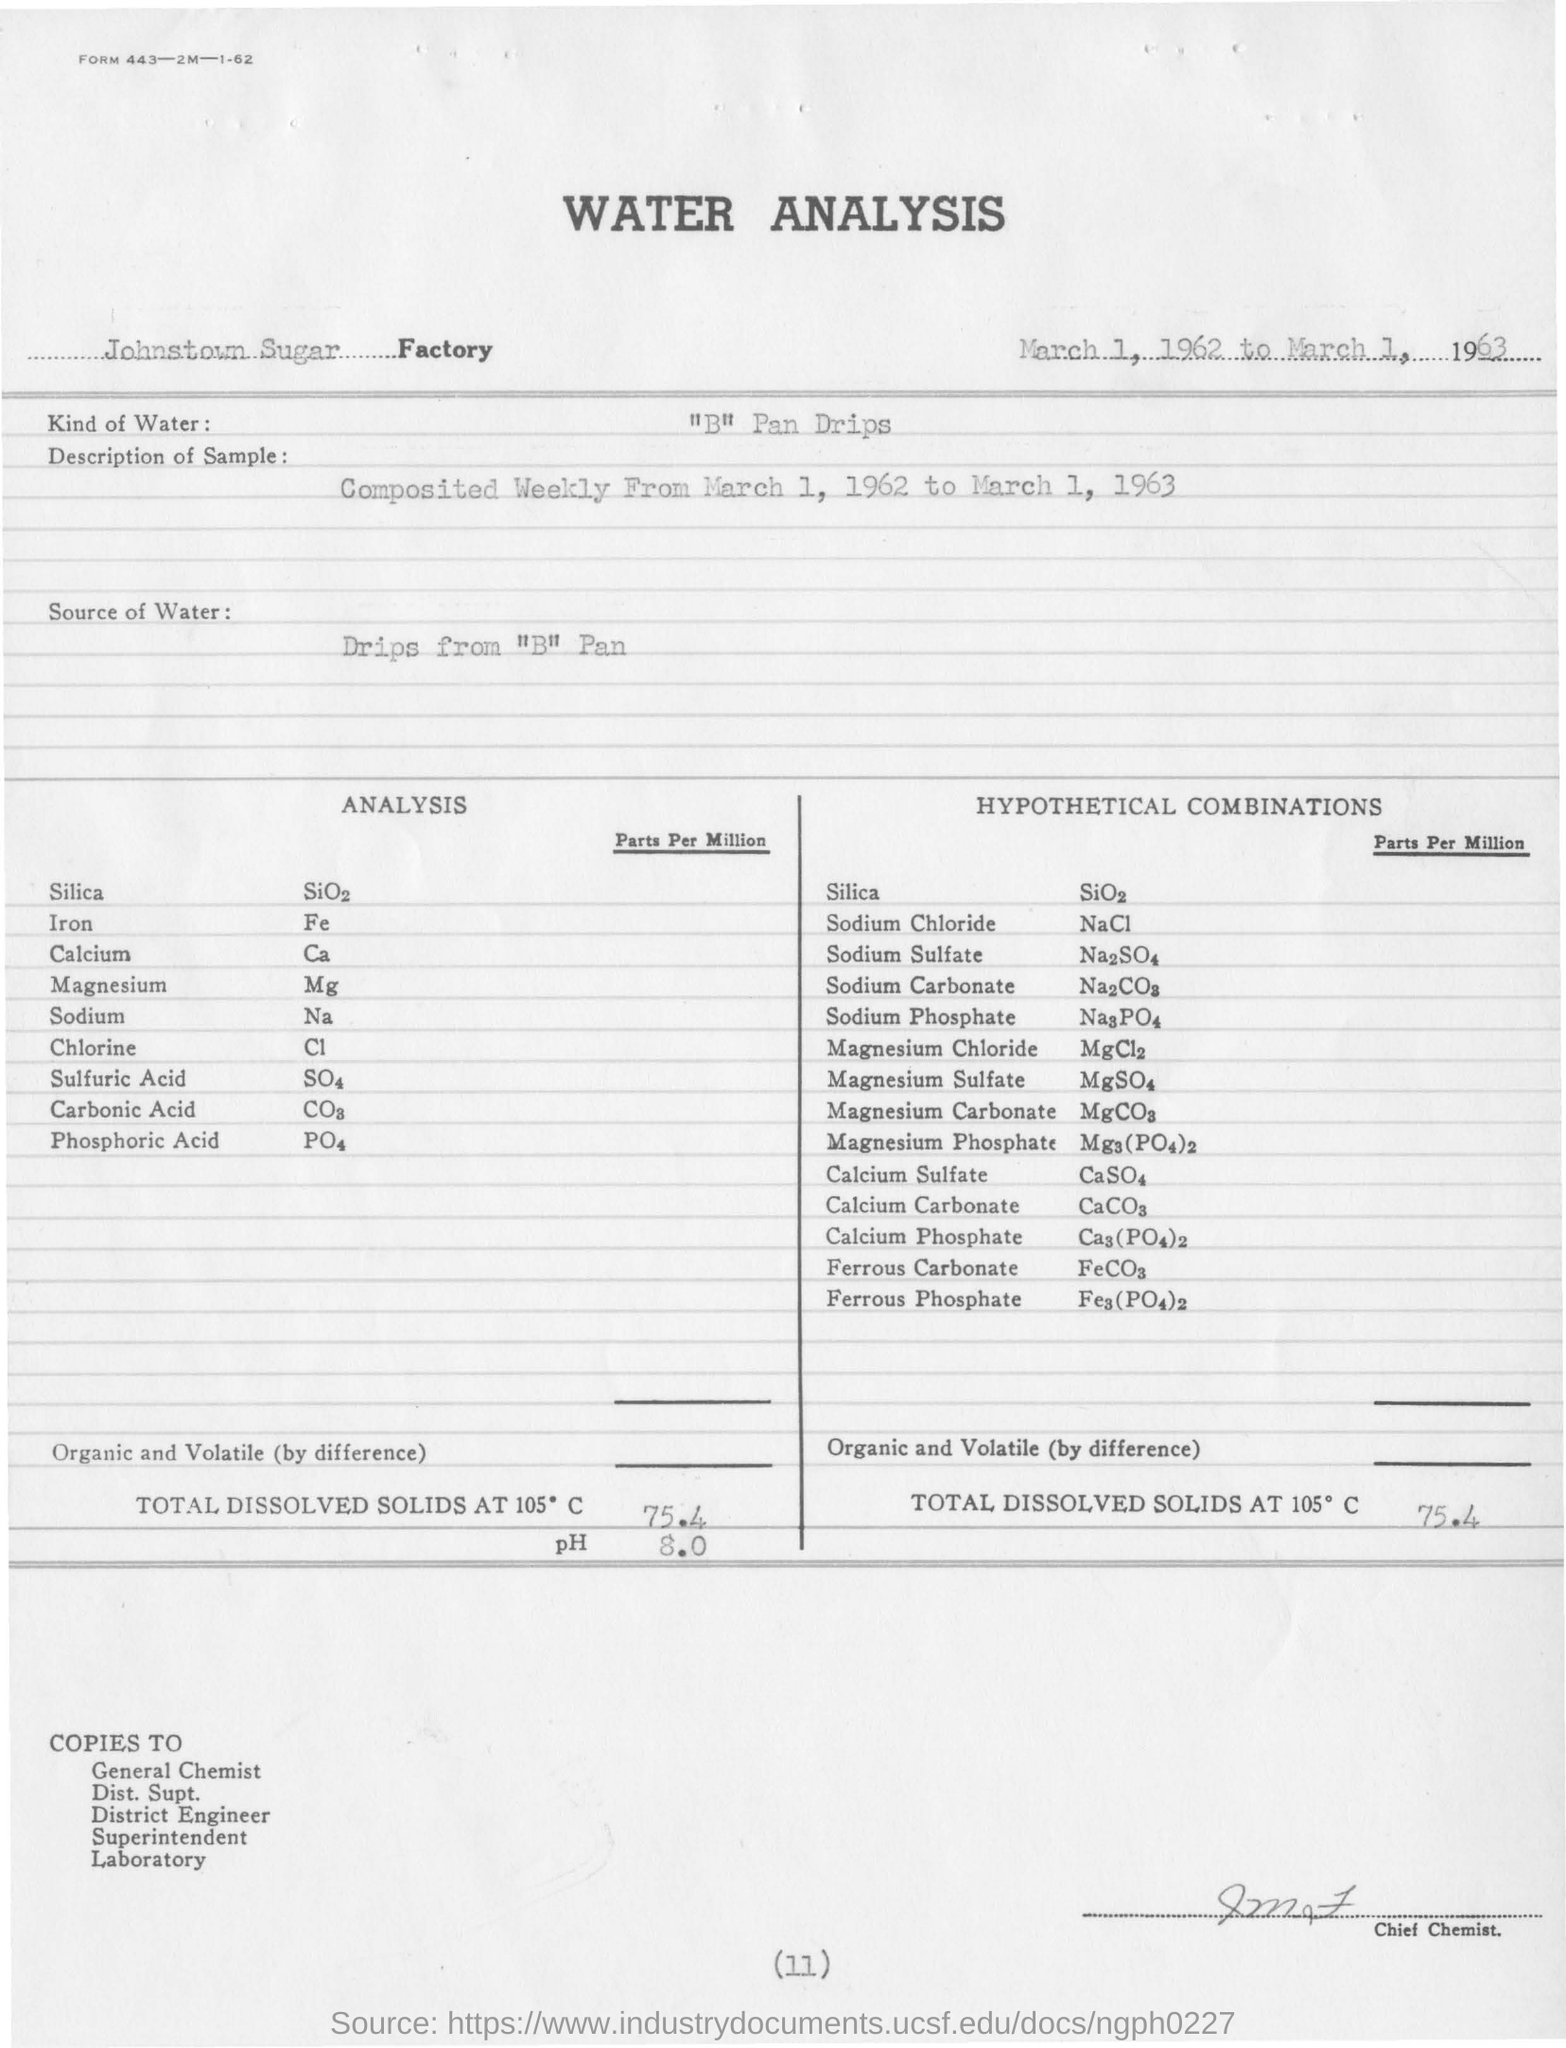List a handful of essential elements in this visual. The pH value obtained from the water analysis is 8.0. For water analysis, a specific type of water is typically used, which is typically obtained from sources such as pan drips. In the given analysis, "Fe" denotes iron. The Johnstown sugar factory conducts water analysis in a factory. The total dissolved solids at 105 degrees Celsius is 75.4 grams. 